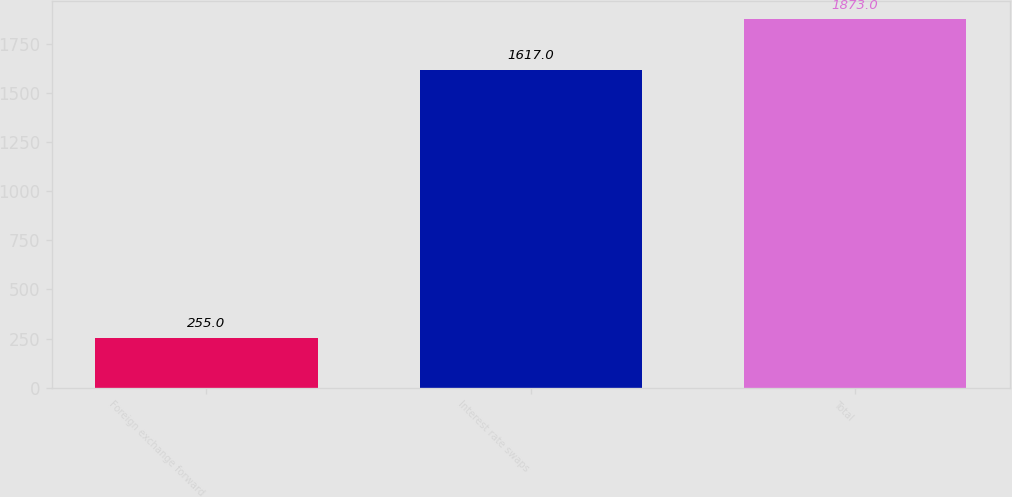Convert chart to OTSL. <chart><loc_0><loc_0><loc_500><loc_500><bar_chart><fcel>Foreign exchange forward<fcel>Interest rate swaps<fcel>Total<nl><fcel>255<fcel>1617<fcel>1873<nl></chart> 